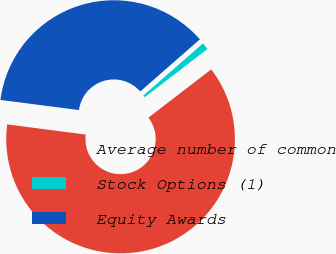Convert chart. <chart><loc_0><loc_0><loc_500><loc_500><pie_chart><fcel>Average number of common<fcel>Stock Options (1)<fcel>Equity Awards<nl><fcel>62.48%<fcel>1.0%<fcel>36.53%<nl></chart> 